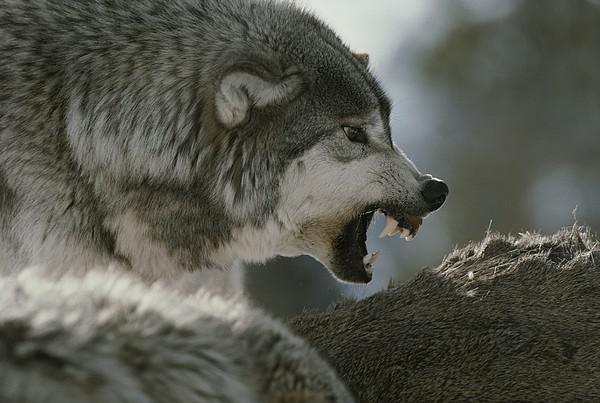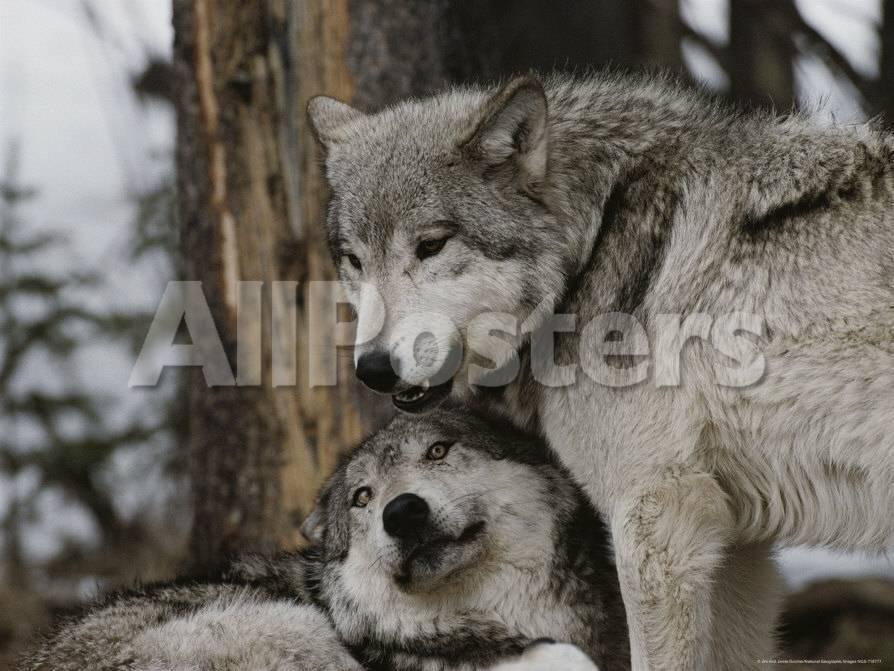The first image is the image on the left, the second image is the image on the right. Considering the images on both sides, is "There is no more than one wolf in the right image." valid? Answer yes or no. No. The first image is the image on the left, the second image is the image on the right. For the images shown, is this caption "One image shows two wolves with one wolf on the ground and one standing, and the other image shows one wolf with all teeth bared and visible." true? Answer yes or no. Yes. 